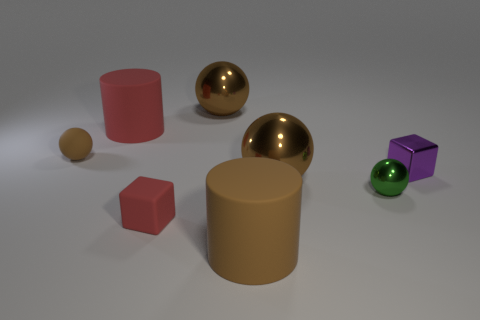How many big things are purple objects or cylinders?
Offer a very short reply. 2. Are there more tiny gray matte cubes than large brown objects?
Keep it short and to the point. No. What is the size of the purple block that is the same material as the small green sphere?
Your response must be concise. Small. There is a green shiny ball that is right of the red rubber cylinder; is it the same size as the cube that is left of the purple metallic block?
Give a very brief answer. Yes. What number of objects are either large brown objects behind the green shiny object or purple metallic blocks?
Your answer should be very brief. 3. Is the number of cubes less than the number of large things?
Offer a very short reply. Yes. The large object that is right of the large cylinder that is in front of the large brown metal ball right of the brown matte cylinder is what shape?
Give a very brief answer. Sphere. The big matte thing that is the same color as the rubber ball is what shape?
Provide a succinct answer. Cylinder. Are any tiny purple metallic blocks visible?
Your answer should be very brief. Yes. There is a rubber ball; is it the same size as the matte cylinder that is left of the red block?
Offer a terse response. No. 